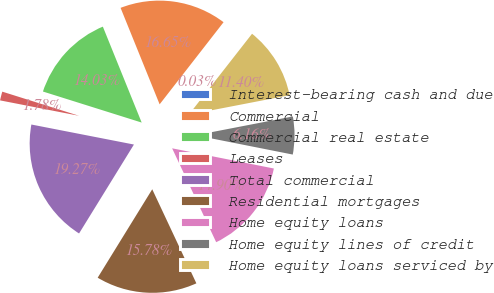Convert chart to OTSL. <chart><loc_0><loc_0><loc_500><loc_500><pie_chart><fcel>Interest-bearing cash and due<fcel>Commercial<fcel>Commercial real estate<fcel>Leases<fcel>Total commercial<fcel>Residential mortgages<fcel>Home equity loans<fcel>Home equity lines of credit<fcel>Home equity loans serviced by<nl><fcel>0.03%<fcel>16.65%<fcel>14.03%<fcel>1.78%<fcel>19.27%<fcel>15.78%<fcel>14.9%<fcel>6.16%<fcel>11.4%<nl></chart> 